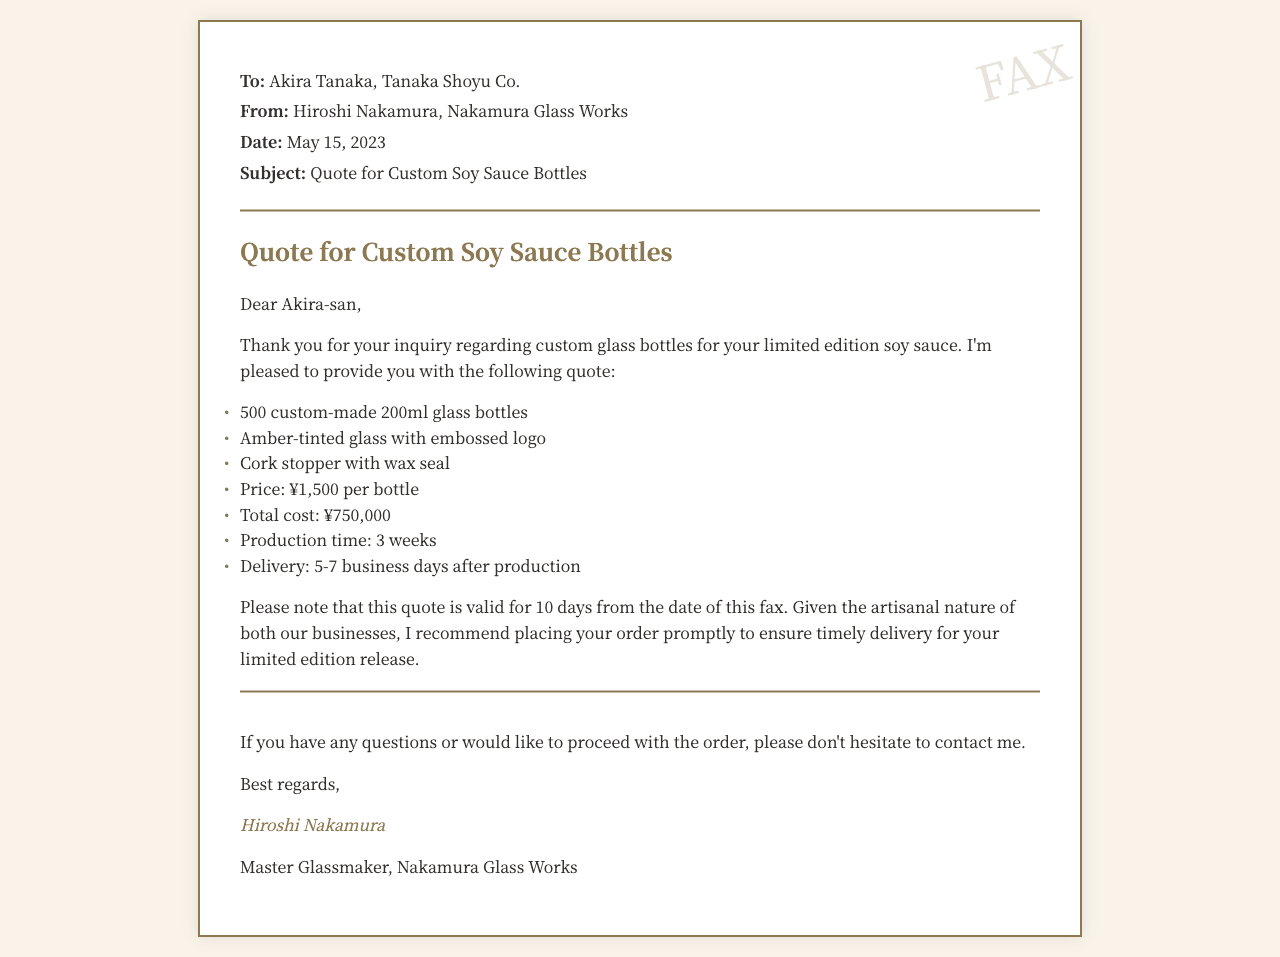What is the name of the sender? The sender of the fax is Hiroshi Nakamura, as mentioned at the top of the document.
Answer: Hiroshi Nakamura What is the total cost for the bottles? The total cost for the 500 custom-made bottles is explicitly stated in the document as ¥750,000.
Answer: ¥750,000 How many bottles are included in the quote? The document states that the quote is for 500 custom-made bottles.
Answer: 500 What is the production time for the bottles? The production time is indicated in the quote as 3 weeks.
Answer: 3 weeks What is the price per bottle? The price per bottle is listed as ¥1,500 in the document.
Answer: ¥1,500 What is the validity period of this quote? The fax states that the quote is valid for 10 days from the date it was sent.
Answer: 10 days What type of glass is mentioned for the bottles? The document specifies that the glasses are Amber-tinted.
Answer: Amber-tinted How should I contact the sender if I have questions? The document encourages contacting Hiroshi Nakamura for any questions, but does not provide specific contact details.
Answer: Contact Hiroshi Nakamura What company does the sender represent? The sender represents Nakamura Glass Works, as indicated in the closing signature of the fax.
Answer: Nakamura Glass Works 